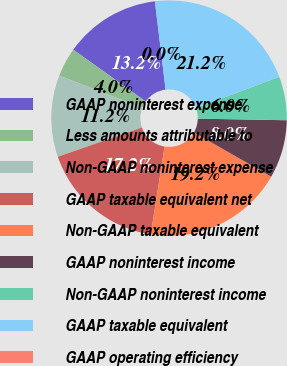<chart> <loc_0><loc_0><loc_500><loc_500><pie_chart><fcel>GAAP noninterest expense<fcel>Less amounts attributable to<fcel>Non-GAAP noninterest expense<fcel>GAAP taxable equivalent net<fcel>Non-GAAP taxable equivalent<fcel>GAAP noninterest income<fcel>Non-GAAP noninterest income<fcel>GAAP taxable equivalent<fcel>GAAP operating efficiency<nl><fcel>13.2%<fcel>4.0%<fcel>11.2%<fcel>17.2%<fcel>19.2%<fcel>8.0%<fcel>6.0%<fcel>21.2%<fcel>0.0%<nl></chart> 